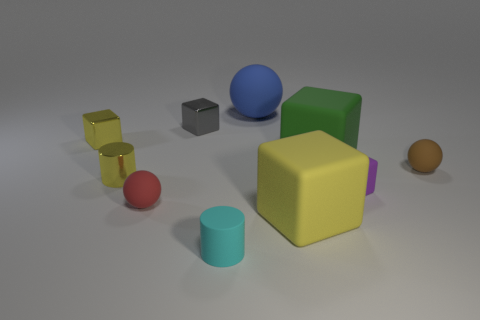There is a cube in front of the purple matte object; is it the same color as the metallic cylinder?
Keep it short and to the point. Yes. There is a large cube that is on the left side of the large block that is behind the sphere on the right side of the tiny purple matte block; what color is it?
Your answer should be very brief. Yellow. What number of green objects are either big rubber blocks or metallic cylinders?
Provide a short and direct response. 1. What number of other things are the same size as the red matte ball?
Your answer should be very brief. 6. What number of large green things are there?
Your answer should be very brief. 1. Do the cylinder to the right of the small red sphere and the large green thing behind the yellow matte block have the same material?
Keep it short and to the point. Yes. What is the gray object made of?
Provide a short and direct response. Metal. What number of large things are the same material as the cyan cylinder?
Your answer should be compact. 3. What number of rubber objects are either big blocks or cubes?
Your answer should be very brief. 3. There is a large rubber object in front of the small purple matte cube; is it the same shape as the large green object behind the red rubber sphere?
Give a very brief answer. Yes. 